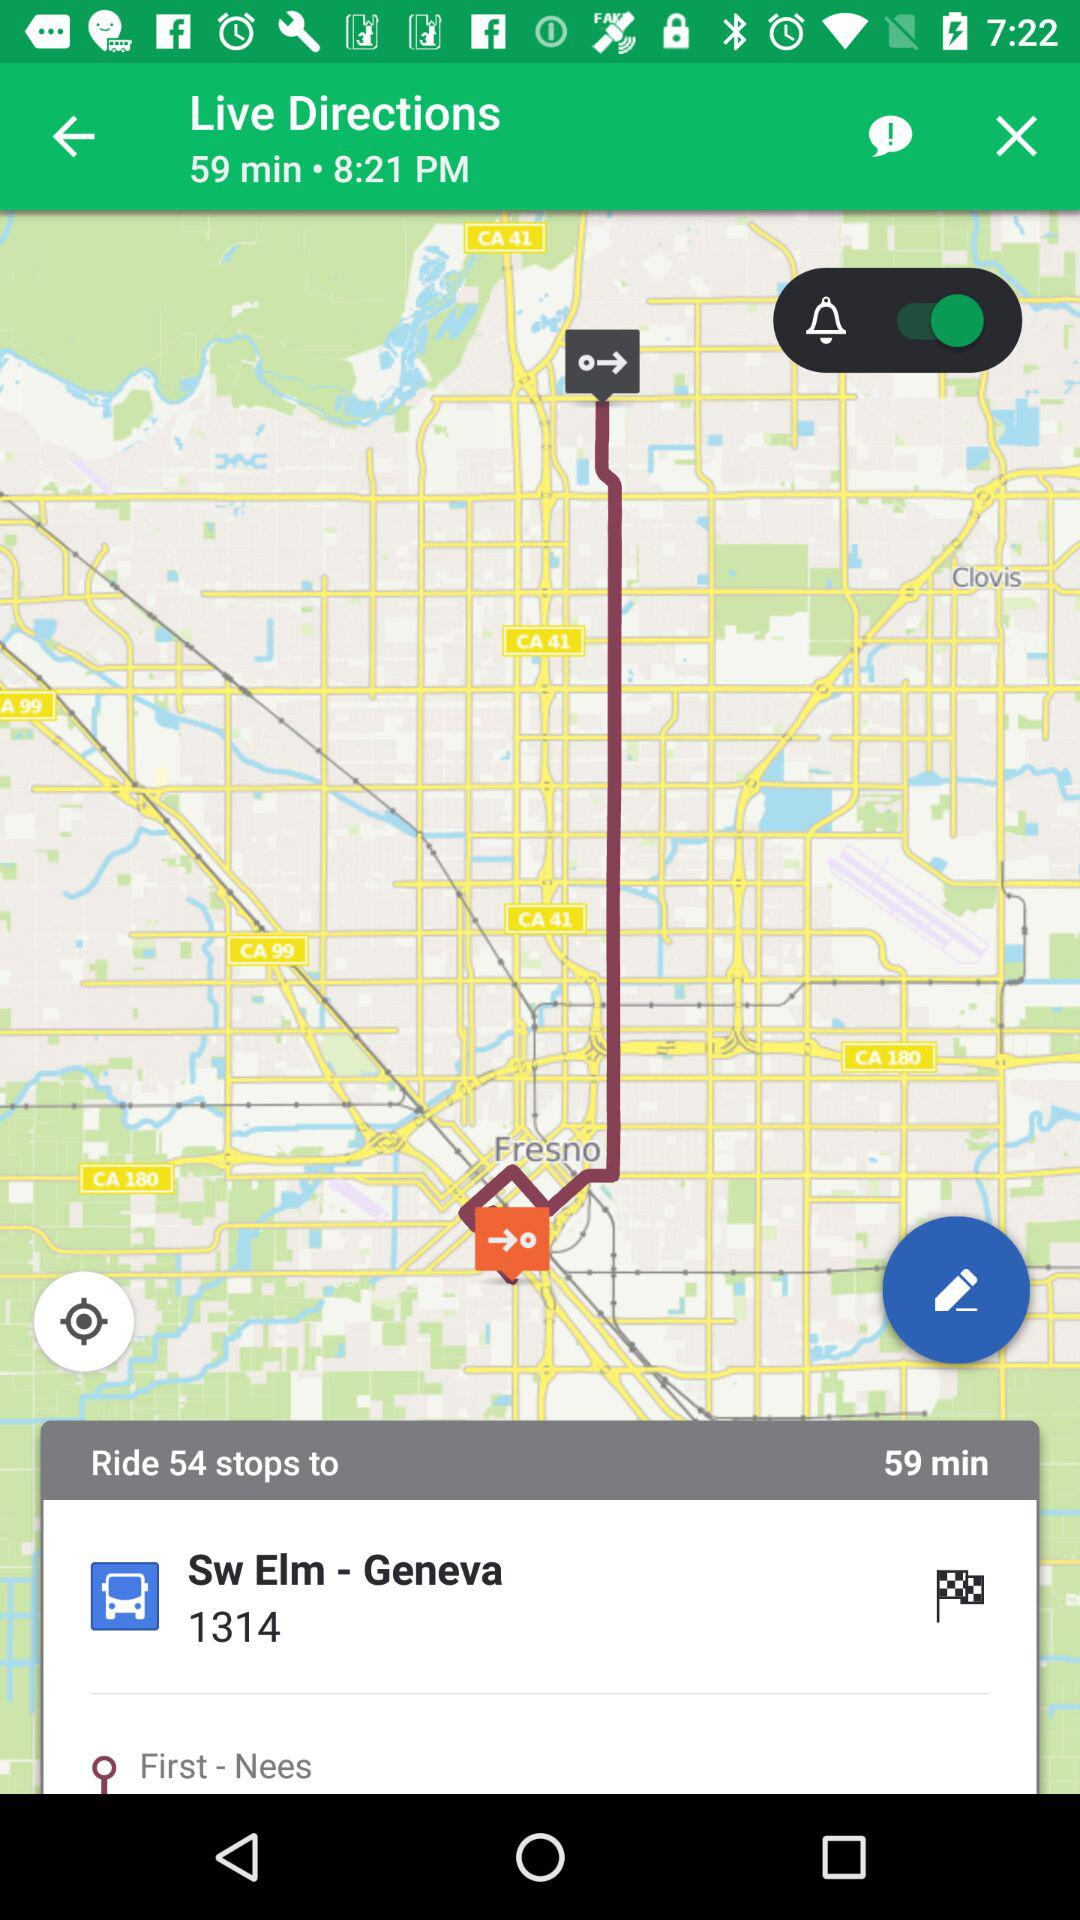How many stops are there in the route?
Answer the question using a single word or phrase. 54 